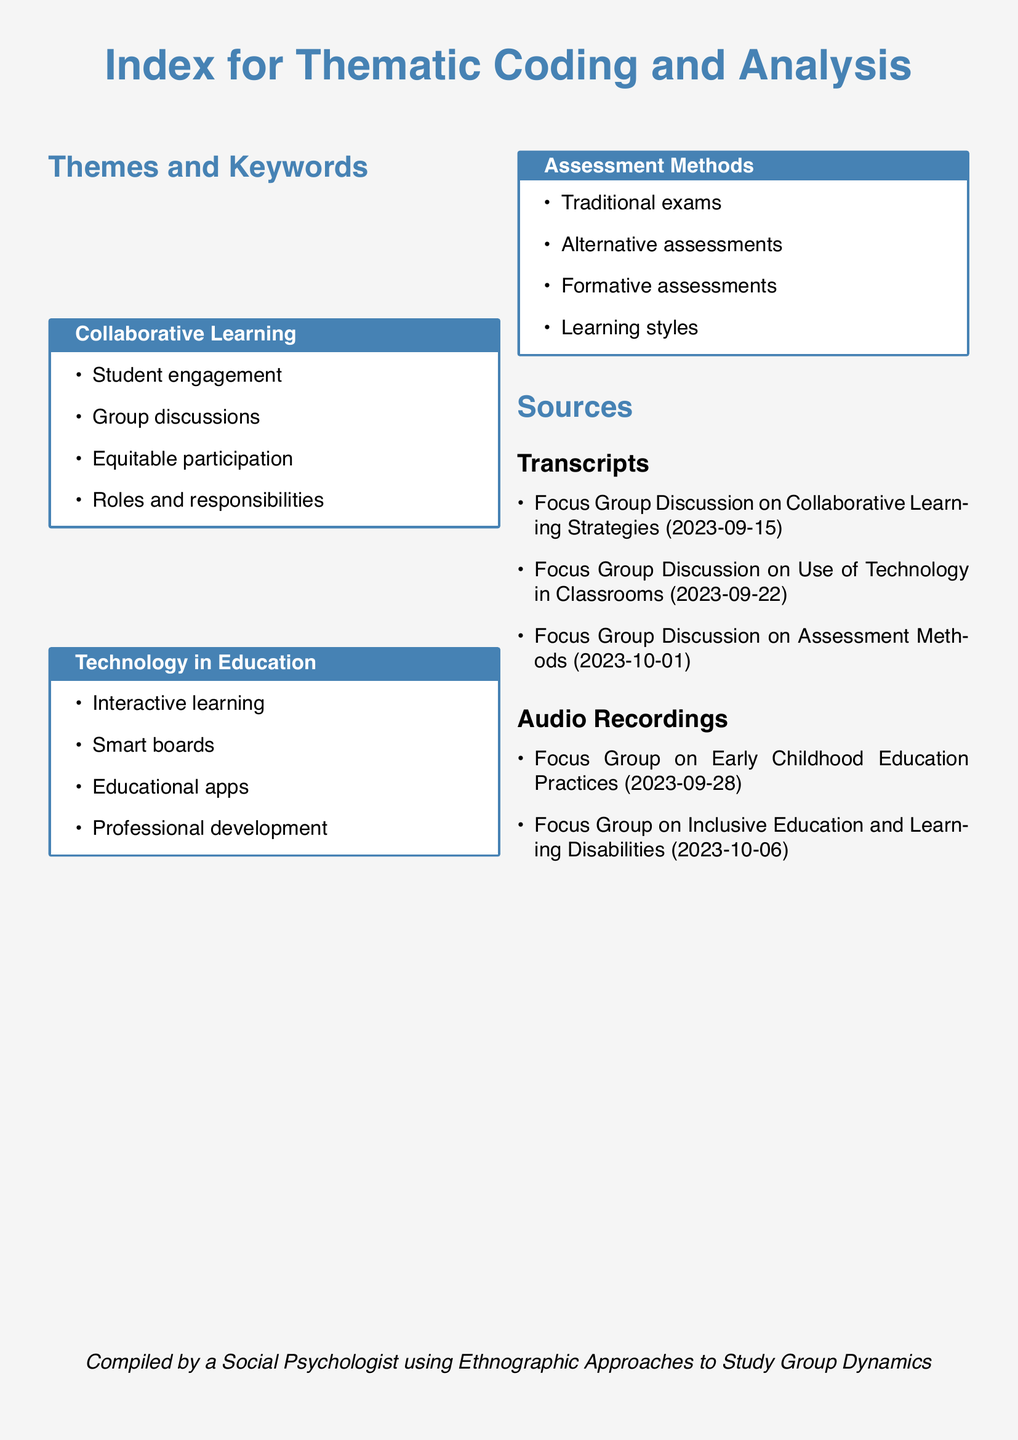What is the theme associated with student engagement? Student engagement is part of the "Collaborative Learning" theme.
Answer: Collaborative Learning How many focus group discussions are listed in the transcripts section? There are three focus group discussions listed in the transcripts section.
Answer: 3 What is one keyword related to technology in education? Keywords related to technology in education include interactive learning.
Answer: Interactive learning On what date was the focus group on assessment methods conducted? The focus group discussion on assessment methods occurred on October 1, 2023.
Answer: 2023-10-01 Which focus group discussion is about inclusive education? The focus group on inclusive education is titled "Inclusive Education and Learning Disabilities."
Answer: Inclusive Education and Learning Disabilities What color theme is used throughout the document? The color theme used throughout the document is a shade of blue.
Answer: Blue How many audio recordings are listed? There are two audio recordings listed in the document.
Answer: 2 What is the subtitle of the source section for transcripts? The subtitle for the sources section for transcripts is simply "Transcripts."
Answer: Transcripts Who compiled the document? The document was compiled by a social psychologist.
Answer: Social Psychologist 